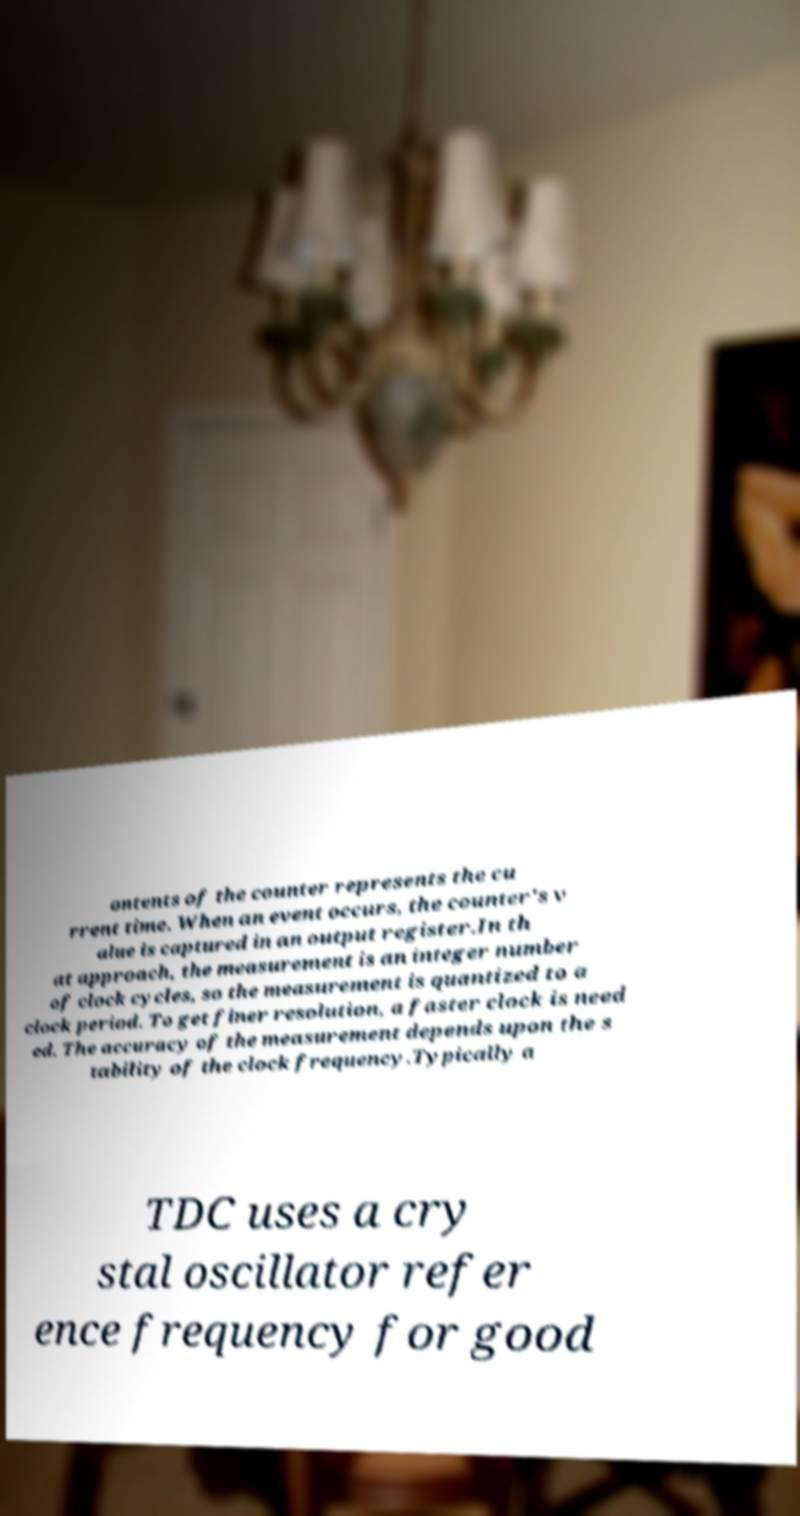Please identify and transcribe the text found in this image. ontents of the counter represents the cu rrent time. When an event occurs, the counter's v alue is captured in an output register.In th at approach, the measurement is an integer number of clock cycles, so the measurement is quantized to a clock period. To get finer resolution, a faster clock is need ed. The accuracy of the measurement depends upon the s tability of the clock frequency.Typically a TDC uses a cry stal oscillator refer ence frequency for good 